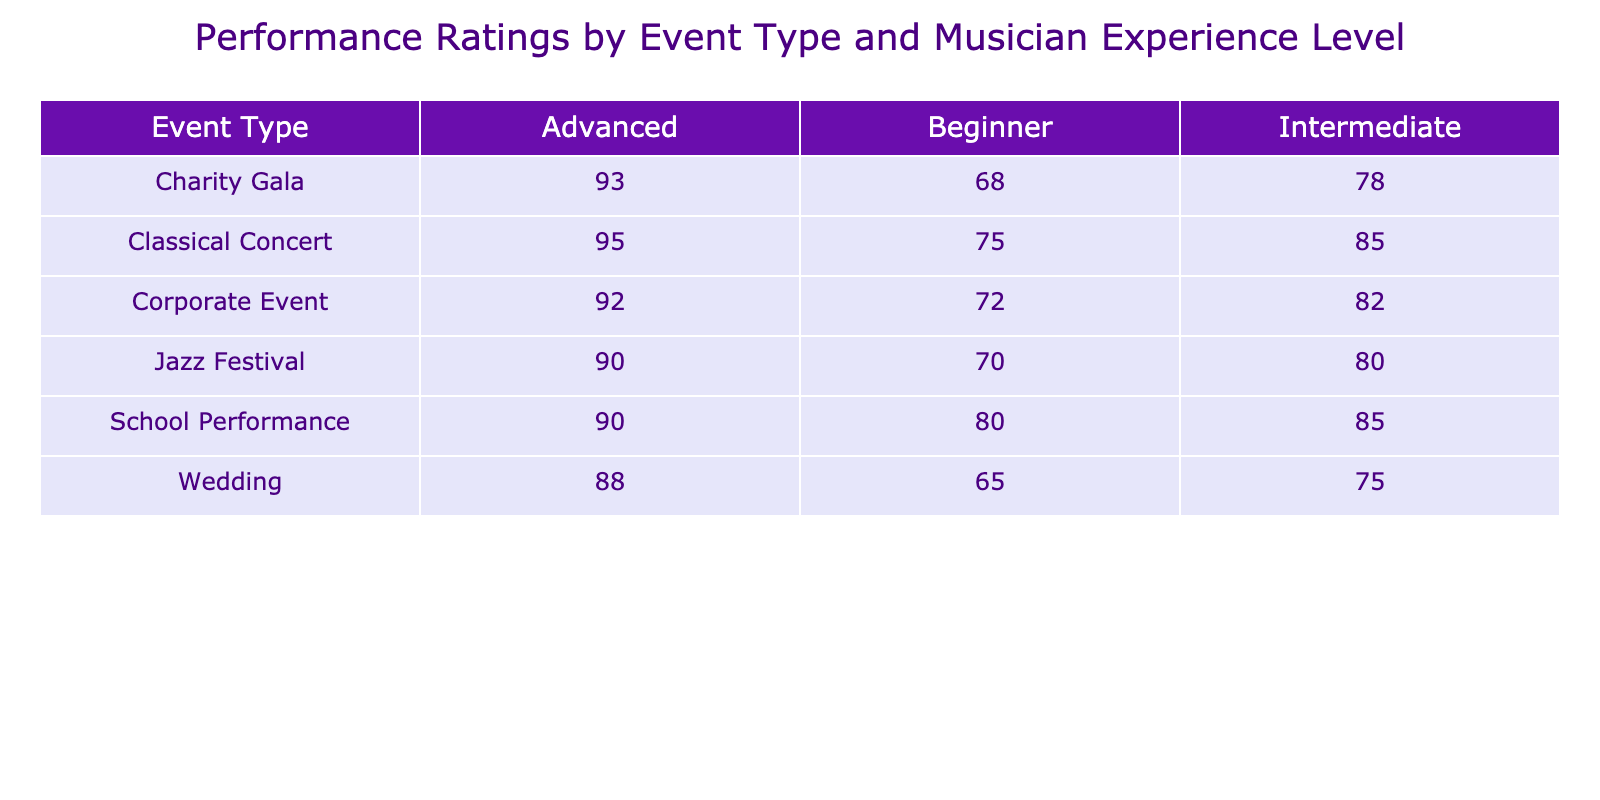What is the performance rating for advanced musicians at jazz festivals? The table shows the performance ratings for different musician experience levels, specifically looking under the "Jazz Festival" row, we find the performance rating for "Advanced" is 90.
Answer: 90 What is the difference between the performance ratings for beginners and advanced musicians at weddings? From the "Wedding" row, the performance rating for "Beginner" is 65 and for "Advanced" is 88. The difference is 88 - 65 = 23.
Answer: 23 Is the performance rating for intermediate musicians at classical concerts higher than that at charity galas? The table indicates a performance rating of 85 for "Intermediate" at "Classical Concerts" and 78 at "Charity Gala". Since 85 is greater than 78, the statement is true.
Answer: Yes What is the average performance rating for beginners across all events? We sum the performance ratings for "Beginner" across all events: 75 (Classical Concert) + 70 (Jazz Festival) + 65 (Wedding) + 72 (Corporate Event) + 68 (Charity Gala) + 80 (School Performance) = 420. There are 6 events, so the average is 420 / 6 = 70.
Answer: 70 Which event type has the highest performance rating for intermediate musicians? By reviewing the "Intermediate" ratings across the events, we see 85 (Classical Concert), 80 (Jazz Festival), 75 (Wedding), 82 (Corporate Event), 78 (Charity Gala), and 85 (School Performance). The maximum of these is 85 at both Classical Concerts and School Performances, making it the highest rating.
Answer: Classical Concert and School Performance 